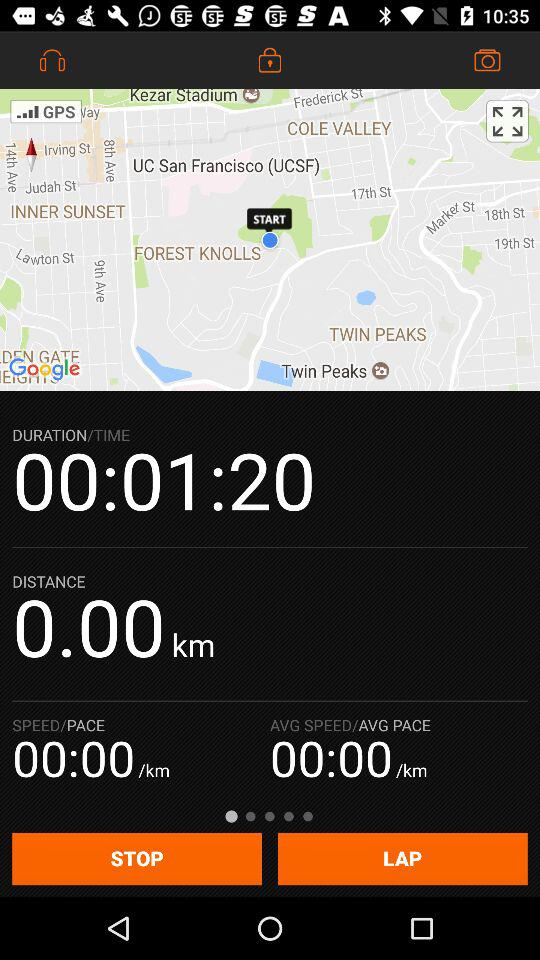What is the current pace?
Answer the question using a single word or phrase. 00:00 